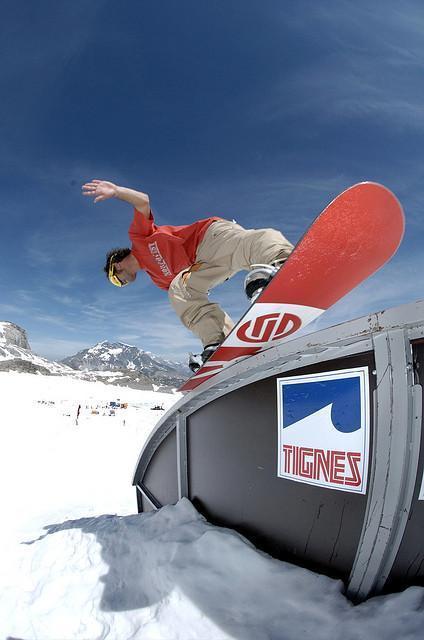How many snowboards are there?
Give a very brief answer. 1. How many trains are there?
Give a very brief answer. 0. 